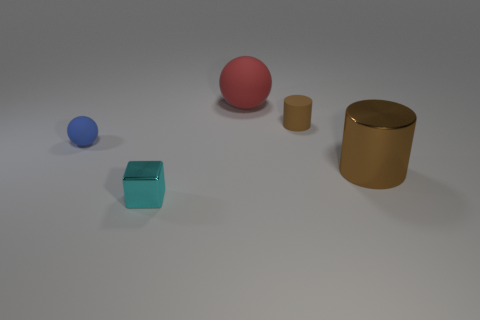Add 2 tiny rubber balls. How many objects exist? 7 Subtract all blocks. How many objects are left? 4 Add 2 tiny shiny objects. How many tiny shiny objects are left? 3 Add 5 small blue things. How many small blue things exist? 6 Subtract 0 green balls. How many objects are left? 5 Subtract all small blocks. Subtract all brown metallic things. How many objects are left? 3 